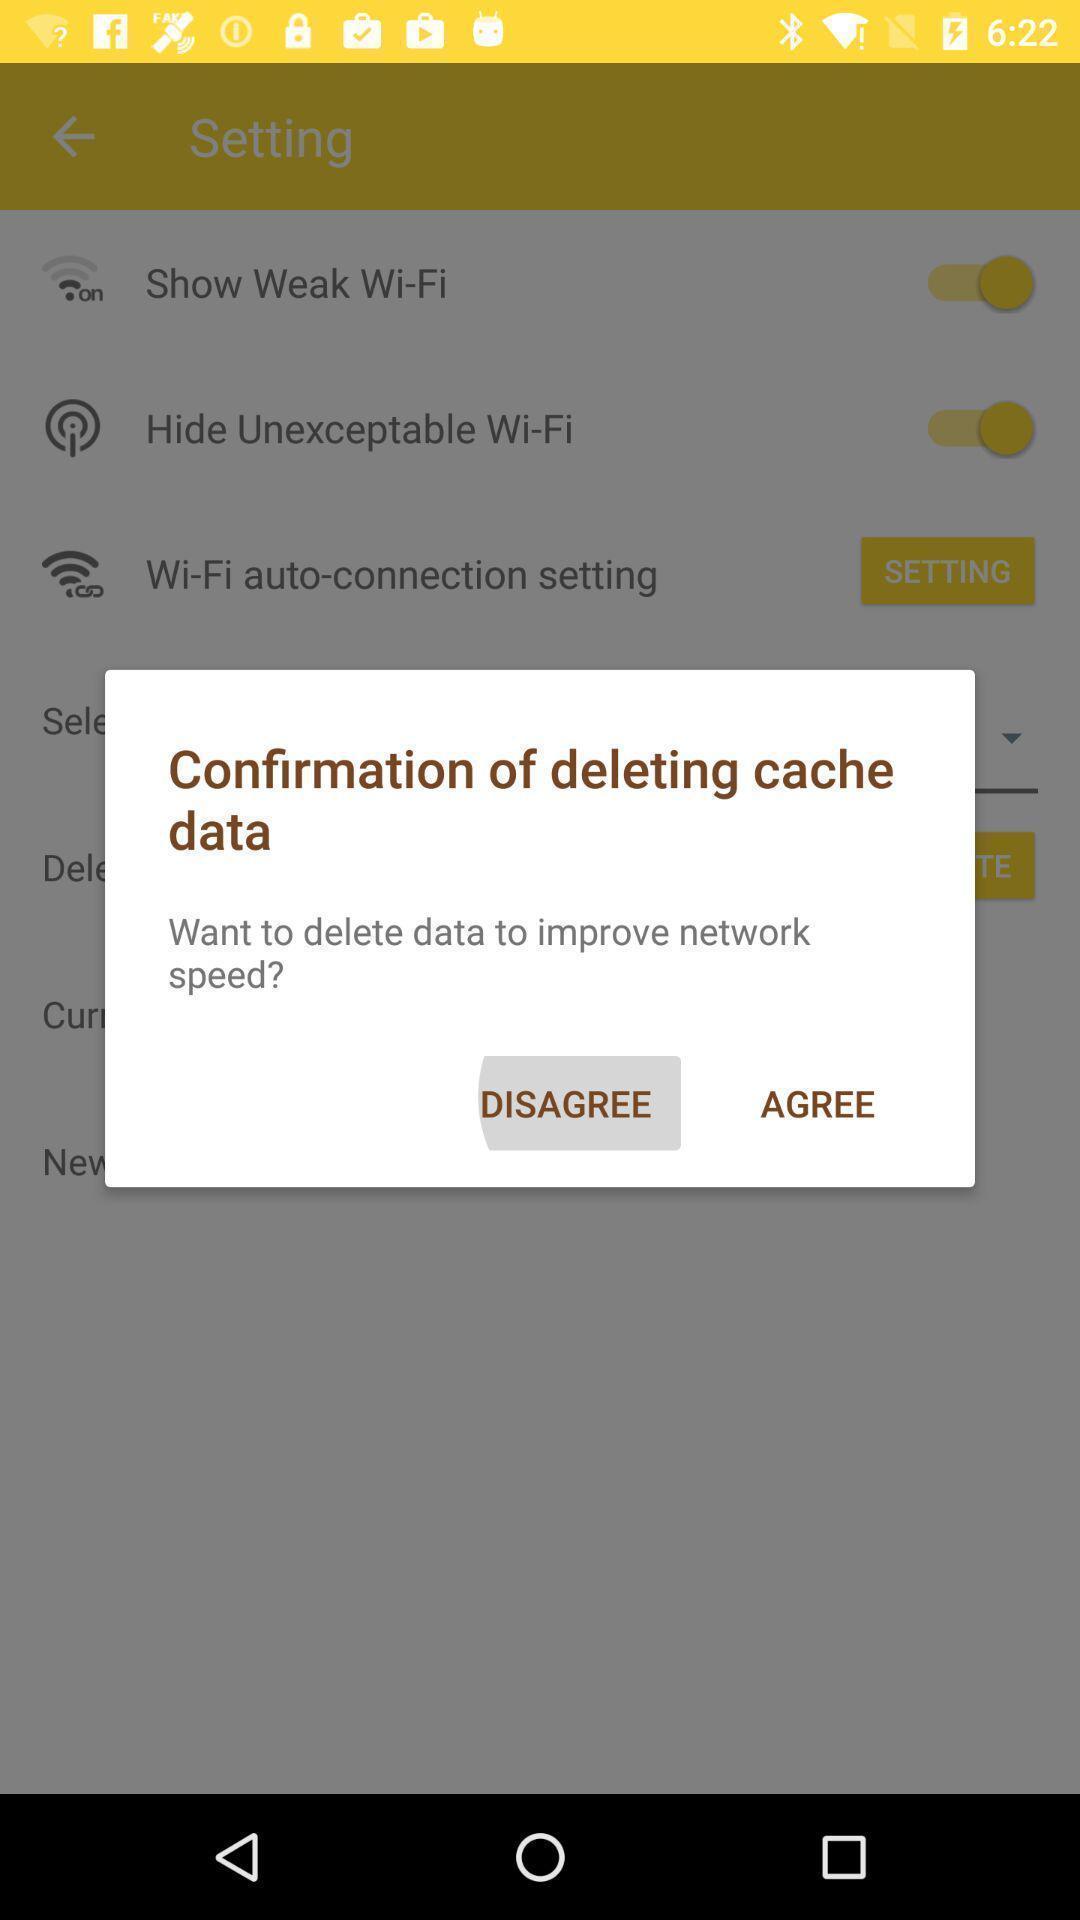What can you discern from this picture? Pop-up showing confirmation of deleting cache data. 